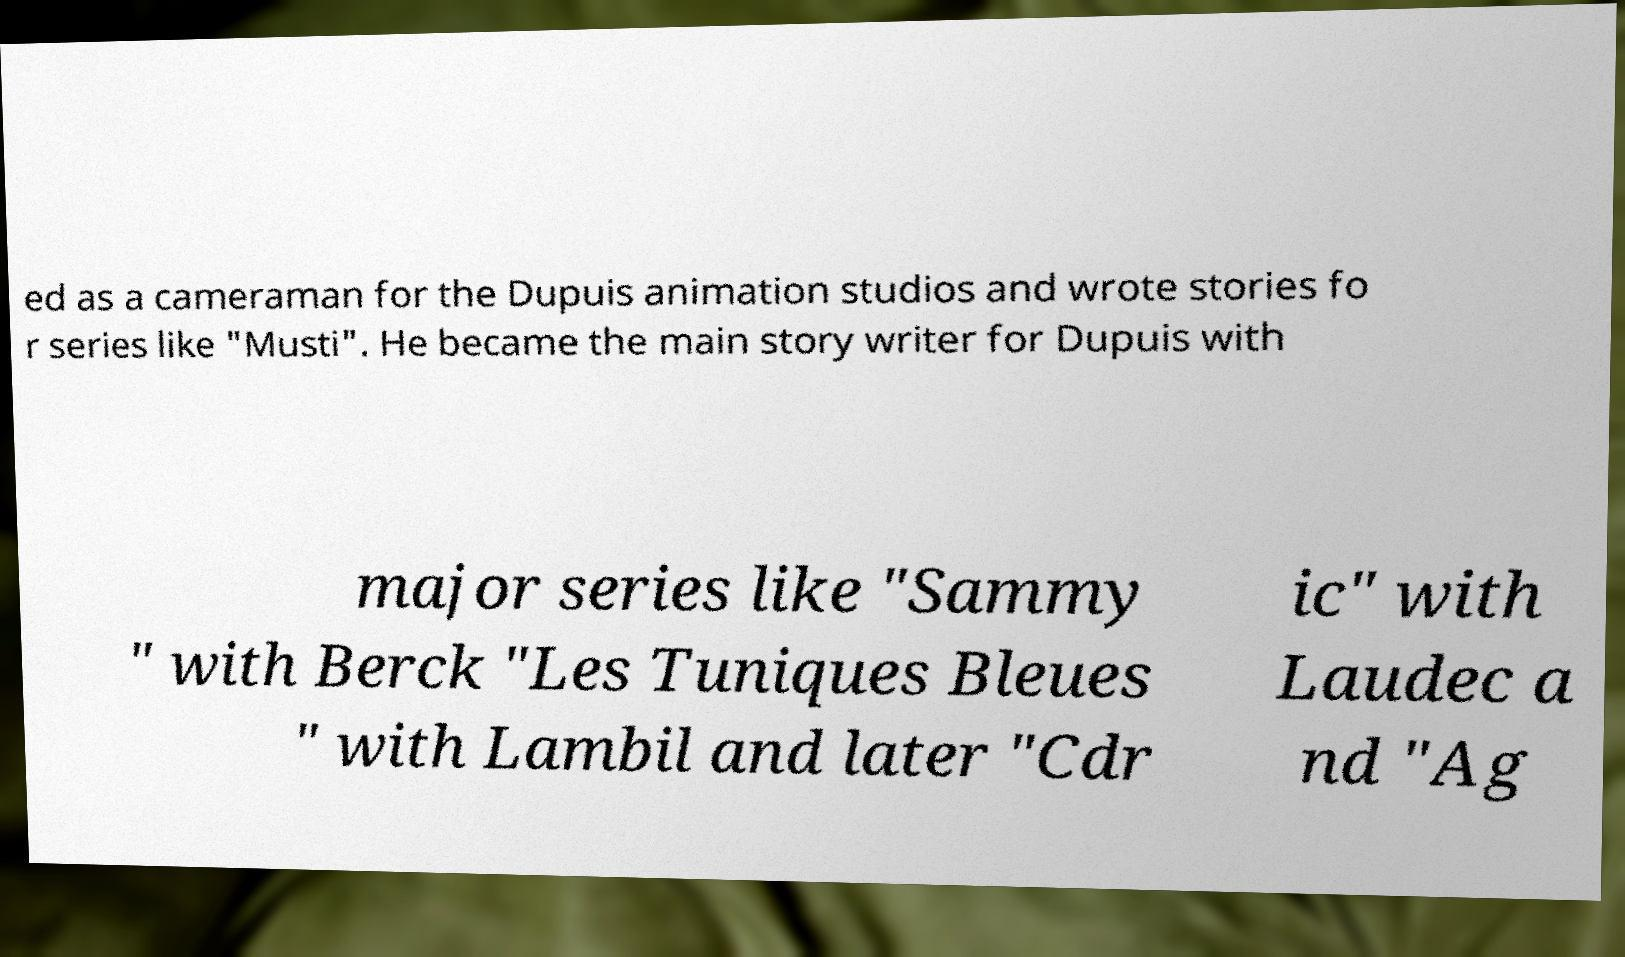Can you accurately transcribe the text from the provided image for me? ed as a cameraman for the Dupuis animation studios and wrote stories fo r series like "Musti". He became the main story writer for Dupuis with major series like "Sammy " with Berck "Les Tuniques Bleues " with Lambil and later "Cdr ic" with Laudec a nd "Ag 